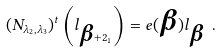<formula> <loc_0><loc_0><loc_500><loc_500>( N _ { \lambda _ { 2 } , \lambda _ { 3 } } ) ^ { t } \left ( l _ { \boldsymbol \beta + 2 _ { 1 } } \right ) = e ( \boldsymbol \beta ) l _ { \boldsymbol \beta } \ .</formula> 